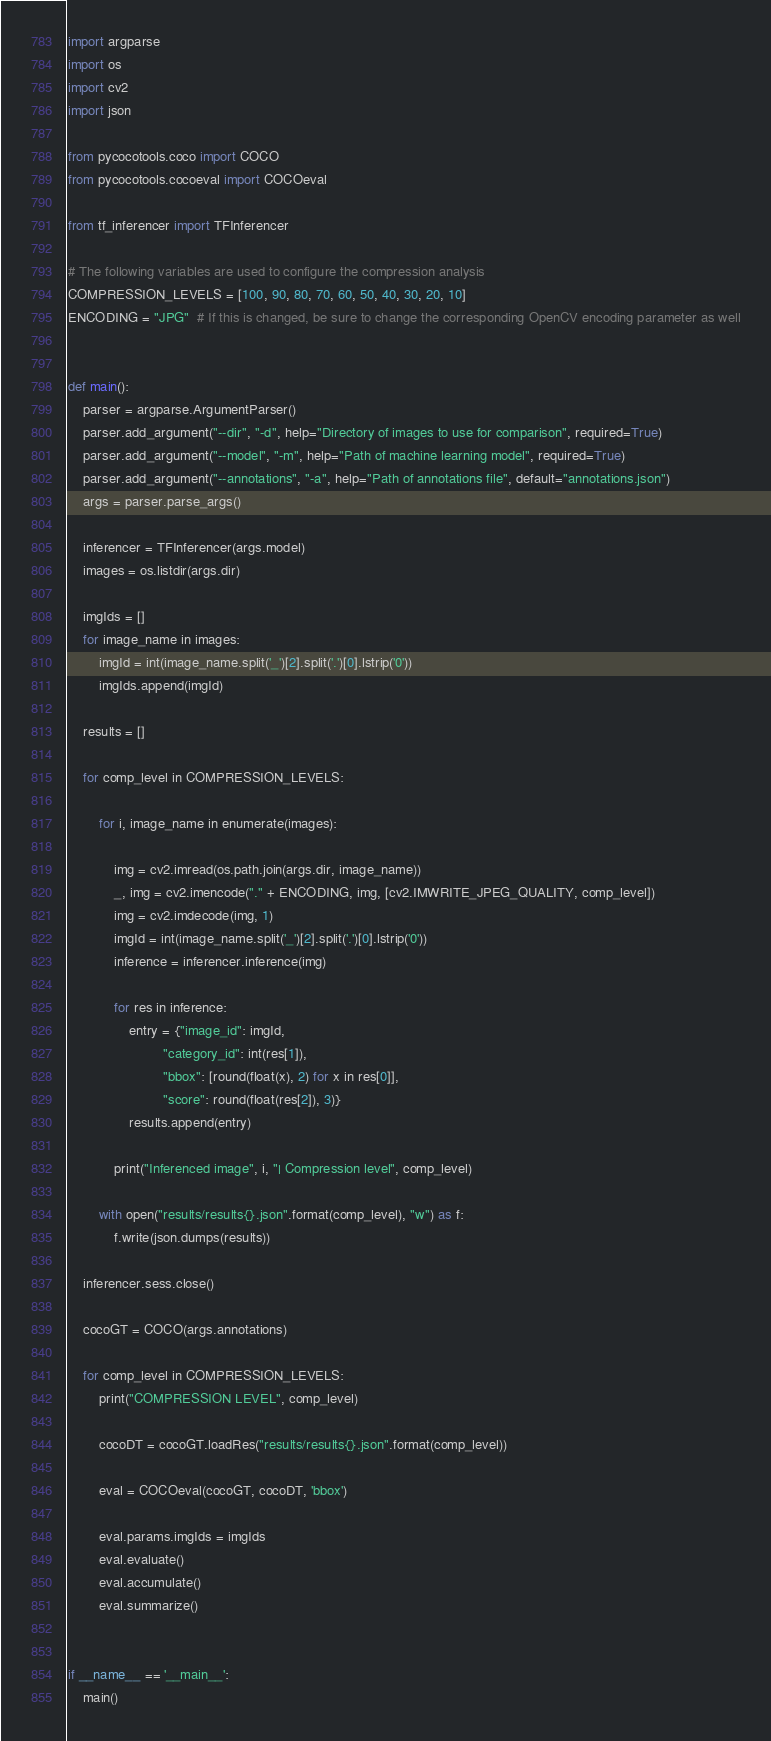Convert code to text. <code><loc_0><loc_0><loc_500><loc_500><_Python_>import argparse
import os
import cv2
import json

from pycocotools.coco import COCO
from pycocotools.cocoeval import COCOeval

from tf_inferencer import TFInferencer

# The following variables are used to configure the compression analysis
COMPRESSION_LEVELS = [100, 90, 80, 70, 60, 50, 40, 30, 20, 10]
ENCODING = "JPG"  # If this is changed, be sure to change the corresponding OpenCV encoding parameter as well


def main():
    parser = argparse.ArgumentParser()
    parser.add_argument("--dir", "-d", help="Directory of images to use for comparison", required=True)
    parser.add_argument("--model", "-m", help="Path of machine learning model", required=True)
    parser.add_argument("--annotations", "-a", help="Path of annotations file", default="annotations.json")
    args = parser.parse_args()

    inferencer = TFInferencer(args.model)
    images = os.listdir(args.dir)

    imgIds = []
    for image_name in images:
        imgId = int(image_name.split('_')[2].split('.')[0].lstrip('0'))
        imgIds.append(imgId)

    results = []

    for comp_level in COMPRESSION_LEVELS:

        for i, image_name in enumerate(images):

            img = cv2.imread(os.path.join(args.dir, image_name))
            _, img = cv2.imencode("." + ENCODING, img, [cv2.IMWRITE_JPEG_QUALITY, comp_level])
            img = cv2.imdecode(img, 1)
            imgId = int(image_name.split('_')[2].split('.')[0].lstrip('0'))
            inference = inferencer.inference(img)

            for res in inference:
                entry = {"image_id": imgId,
                         "category_id": int(res[1]),
                         "bbox": [round(float(x), 2) for x in res[0]],
                         "score": round(float(res[2]), 3)}
                results.append(entry)

            print("Inferenced image", i, "| Compression level", comp_level)

        with open("results/results{}.json".format(comp_level), "w") as f:
            f.write(json.dumps(results))

    inferencer.sess.close()

    cocoGT = COCO(args.annotations)

    for comp_level in COMPRESSION_LEVELS:
        print("COMPRESSION LEVEL", comp_level)

        cocoDT = cocoGT.loadRes("results/results{}.json".format(comp_level))

        eval = COCOeval(cocoGT, cocoDT, 'bbox')

        eval.params.imgIds = imgIds
        eval.evaluate()
        eval.accumulate()
        eval.summarize()


if __name__ == '__main__':
    main()
</code> 